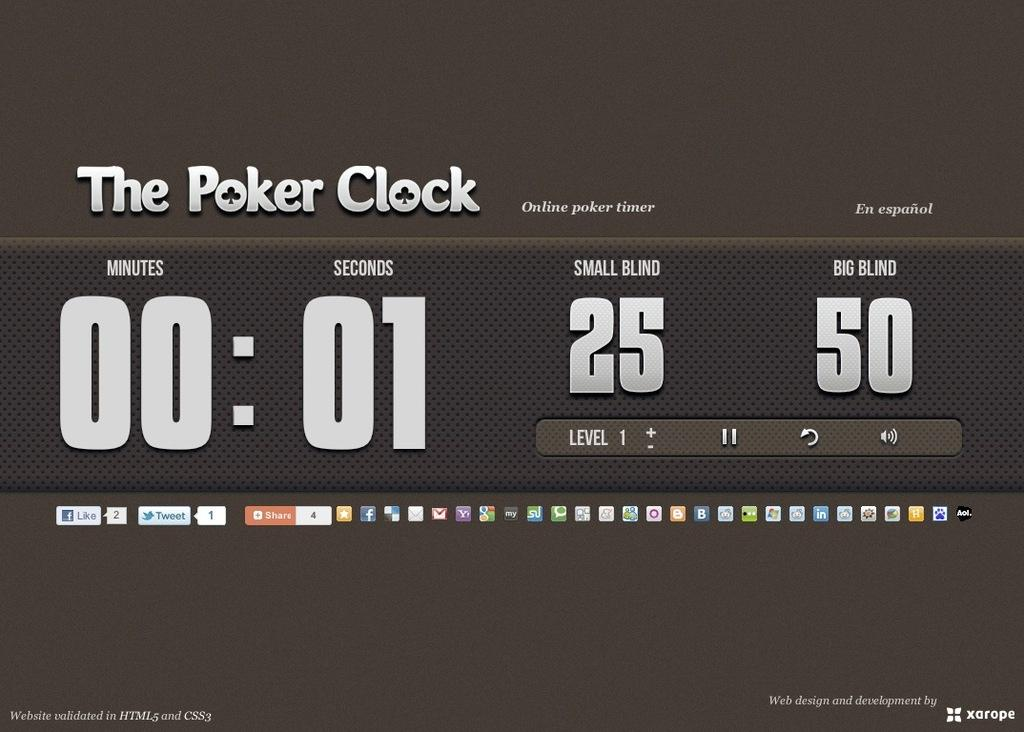<image>
Give a short and clear explanation of the subsequent image. Screen that shows The Poker Clock currently at 1 second. 